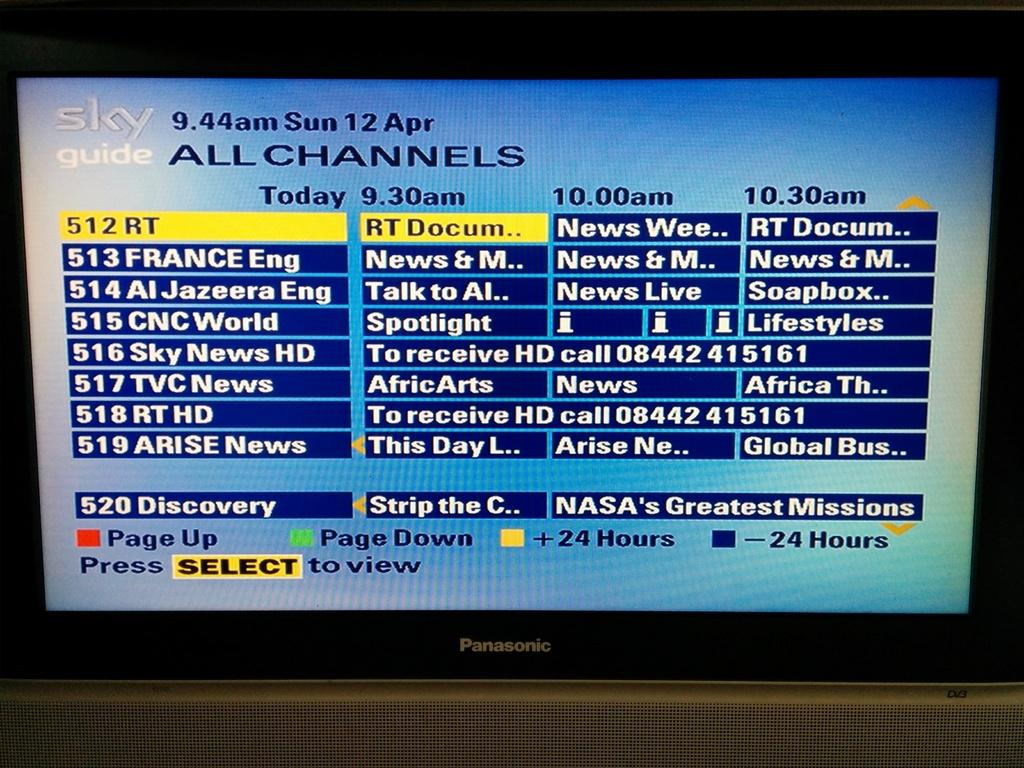<image>
Share a concise interpretation of the image provided. The guide on the tv screen reads as SKY 